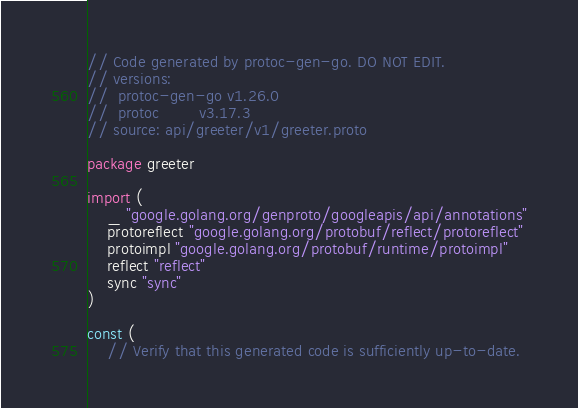<code> <loc_0><loc_0><loc_500><loc_500><_Go_>// Code generated by protoc-gen-go. DO NOT EDIT.
// versions:
// 	protoc-gen-go v1.26.0
// 	protoc        v3.17.3
// source: api/greeter/v1/greeter.proto

package greeter

import (
	_ "google.golang.org/genproto/googleapis/api/annotations"
	protoreflect "google.golang.org/protobuf/reflect/protoreflect"
	protoimpl "google.golang.org/protobuf/runtime/protoimpl"
	reflect "reflect"
	sync "sync"
)

const (
	// Verify that this generated code is sufficiently up-to-date.</code> 